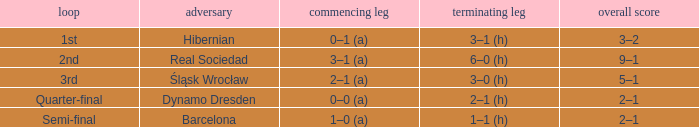What was the first leg score against Real Sociedad? 3–1 (a). 